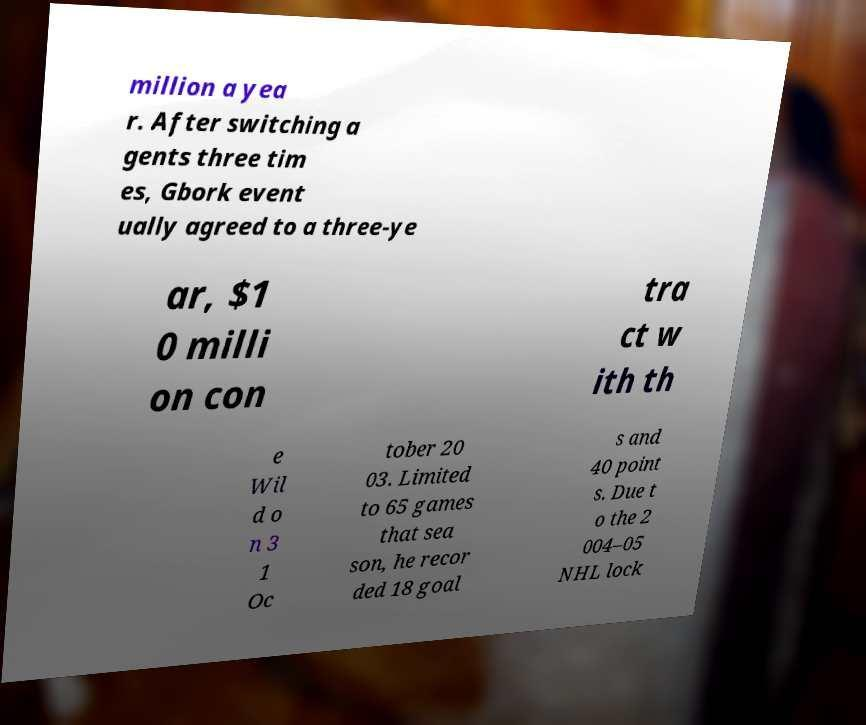For documentation purposes, I need the text within this image transcribed. Could you provide that? million a yea r. After switching a gents three tim es, Gbork event ually agreed to a three-ye ar, $1 0 milli on con tra ct w ith th e Wil d o n 3 1 Oc tober 20 03. Limited to 65 games that sea son, he recor ded 18 goal s and 40 point s. Due t o the 2 004–05 NHL lock 